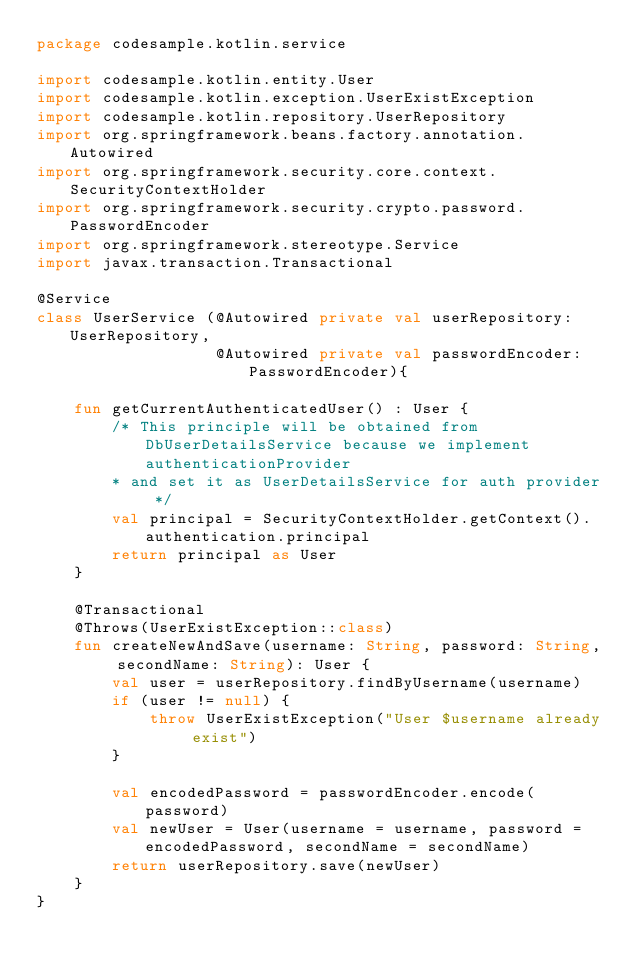<code> <loc_0><loc_0><loc_500><loc_500><_Kotlin_>package codesample.kotlin.service

import codesample.kotlin.entity.User
import codesample.kotlin.exception.UserExistException
import codesample.kotlin.repository.UserRepository
import org.springframework.beans.factory.annotation.Autowired
import org.springframework.security.core.context.SecurityContextHolder
import org.springframework.security.crypto.password.PasswordEncoder
import org.springframework.stereotype.Service
import javax.transaction.Transactional

@Service
class UserService (@Autowired private val userRepository: UserRepository,
                   @Autowired private val passwordEncoder: PasswordEncoder){

    fun getCurrentAuthenticatedUser() : User {
        /* This principle will be obtained from DbUserDetailsService because we implement authenticationProvider
        * and set it as UserDetailsService for auth provider */
        val principal = SecurityContextHolder.getContext().authentication.principal
        return principal as User
    }

    @Transactional
    @Throws(UserExistException::class)
    fun createNewAndSave(username: String, password: String, secondName: String): User {
        val user = userRepository.findByUsername(username)
        if (user != null) {
            throw UserExistException("User $username already exist")
        }

        val encodedPassword = passwordEncoder.encode(password)
        val newUser = User(username = username, password = encodedPassword, secondName = secondName)
        return userRepository.save(newUser)
    }
}</code> 